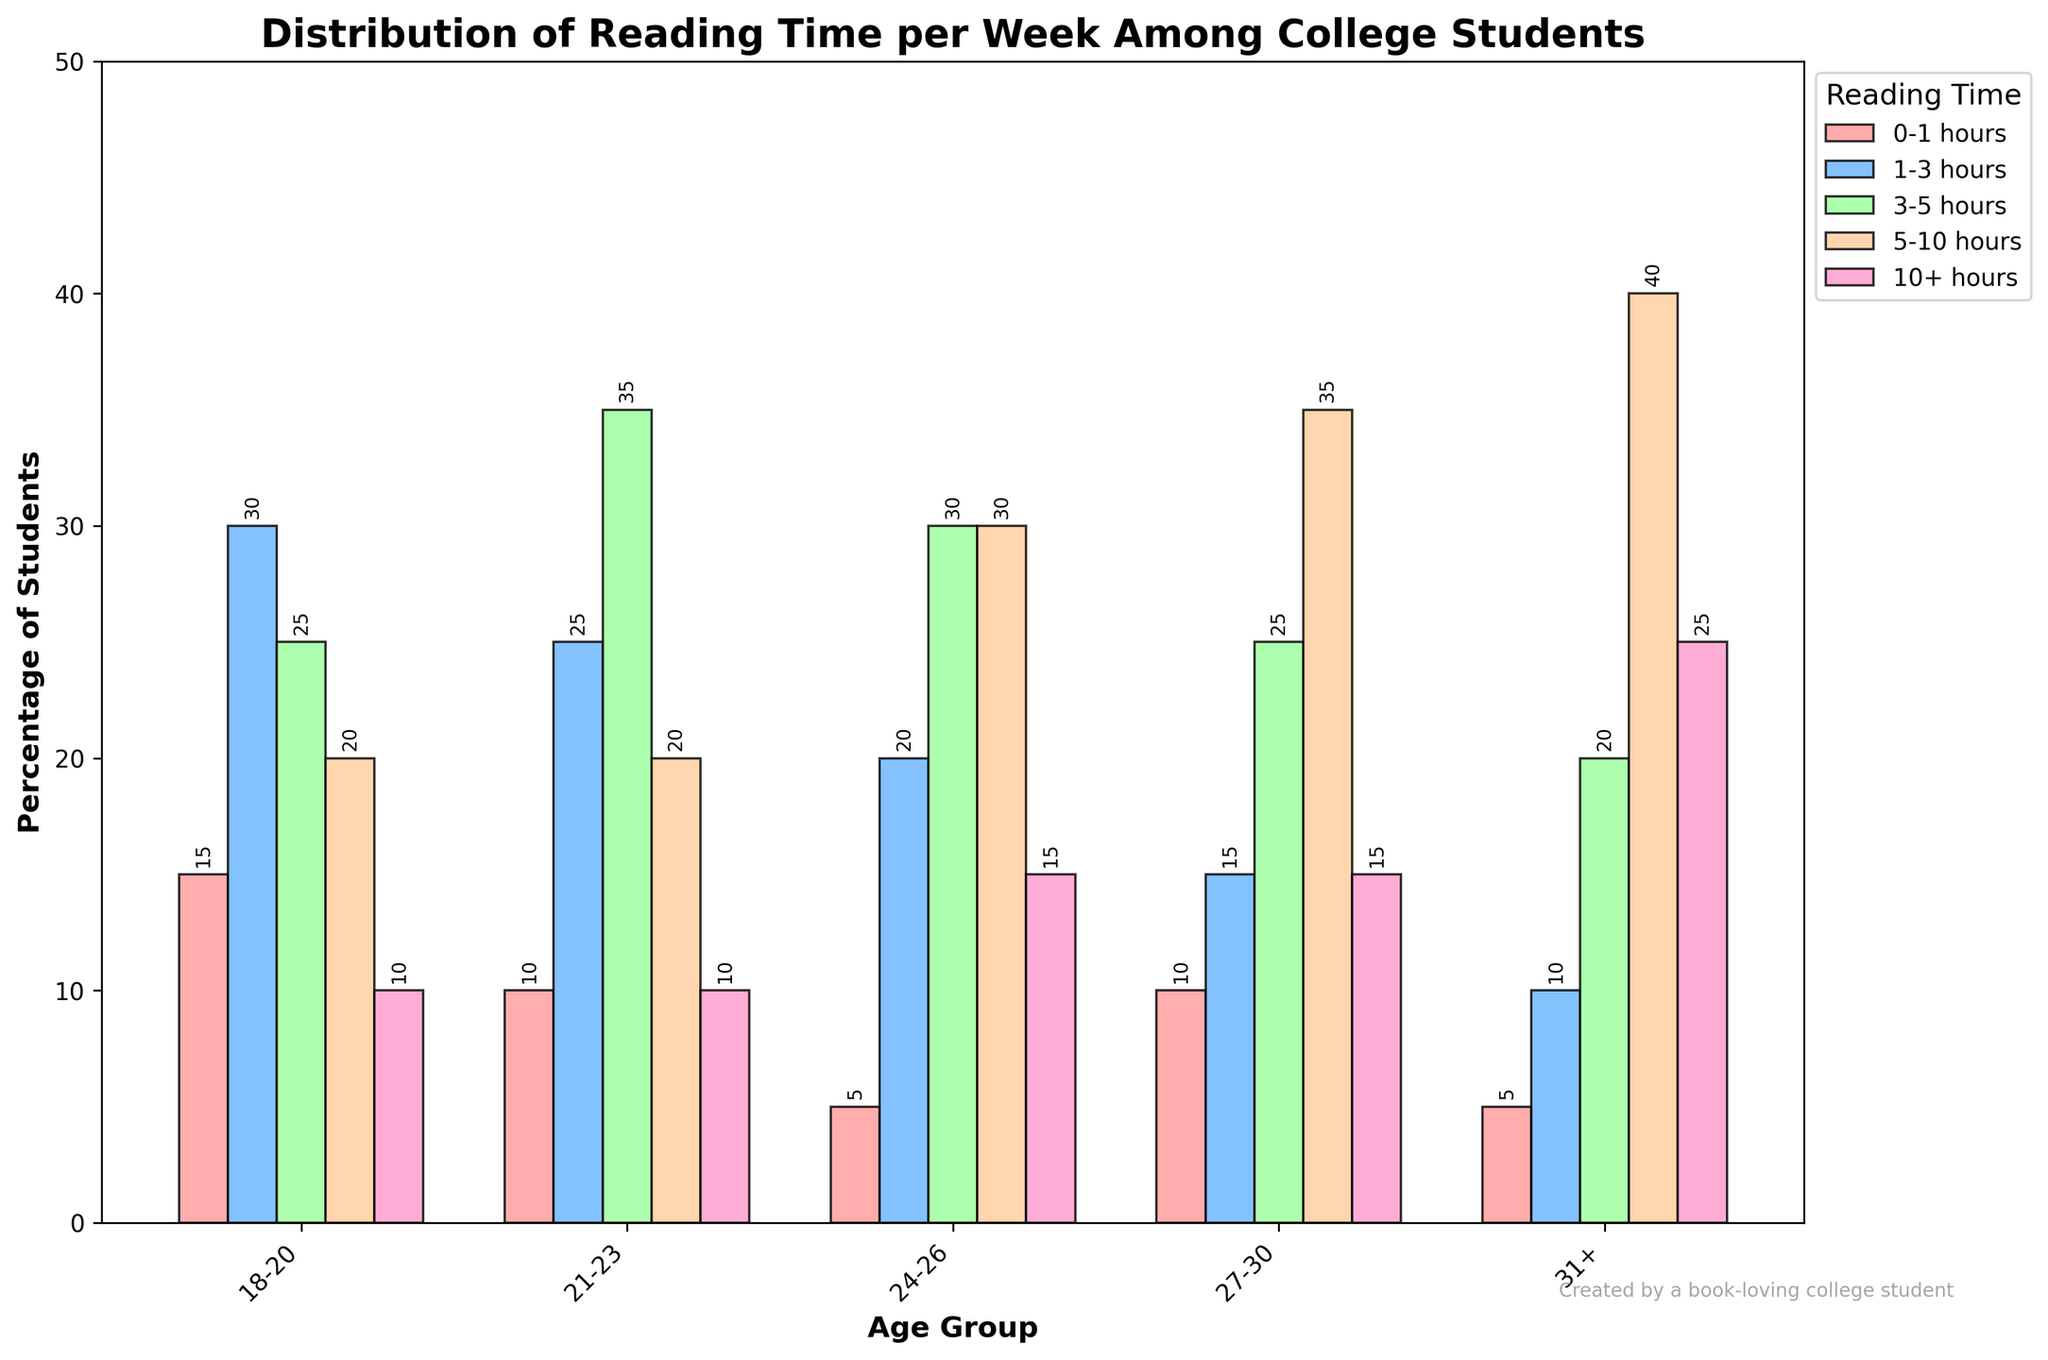What is the most common reading time for the age group 18-20? Look at the age group 18-20 and identify the tallest bar. The tallest bar is "1-3 hours," with 30% of students reading for this duration.
Answer: 1-3 hours Which age group has the highest percentage of students reading for 10+ hours? Identify the bar representing 10+ hours and find the tallest bar across different age groups. The tallest bar for 10+ hours is in the "31+" age group, standing at 25%.
Answer: 31+ What is the total percentage of students aged 24-26 who read for 5-10 hours? Look at the age group 24-26 and focus on the bar representing 5-10 hours. This bar has a value of 30%.
Answer: 30% Which age group shows a higher percentage of students reading 3-5 hours per week, 21-23 or 27-30? Compare the bars for 3-5 hours in the 21-23 and 27-30 age groups. The bar for the 21-23 age group is higher at 35%, while it is 25% for the 27-30 age group.
Answer: 21-23 What is the percentage difference between students aged 31+ reading 0-1 hours and students aged 24-26 reading 0-1 hours? Identify the bars for 0-1 hours for both age groups: 5% for 31+ and 5% for 24-26. The difference is 0%.
Answer: 0% Which age group has the smallest percentage of students reading for 0-1 hours? Identify the bar representing 0-1 hours across all age groups. The "24-26" age group and the "31+" age group both have the smallest bars at 5%.
Answer: 24-26 and 31+ How does the reading time distribution differ between the age groups 18-20 and 31+? Compare the height of the bars for each reading time category between the two groups. The 18-20 group has the highest percentage in the 1-3 hours category, while the 31+ group peaks in the 5-10 hours category. For 10+ hours, the 31+ group has a much higher percentage (25%) compared to the 18-20 group (10%).
Answer: 18-20 group reads more in shorter durations (1-3 hours), while 31+ group reads more in longer durations (5-10 hours and 10+ hours) In which age group is the difference the smallest between the highest and the lowest percentage of students reading for different durations? Identify the highest and lowest percentages for each age group and calculate their difference:  
- 18-20: 30% (highest) - 10% (lowest) = 20%
- 21-23: 35% (highest) - 10% (lowest) = 25%
- 24-26: 30% (highest) - 5% (lowest) = 25%
- 27-30: 35% (highest) - 10% (lowest) = 25%
- 31+: 40% (highest) - 5% (lowest) = 35%  
The smallest difference is for the 18-20 age group with 20%.
Answer: 18-20 